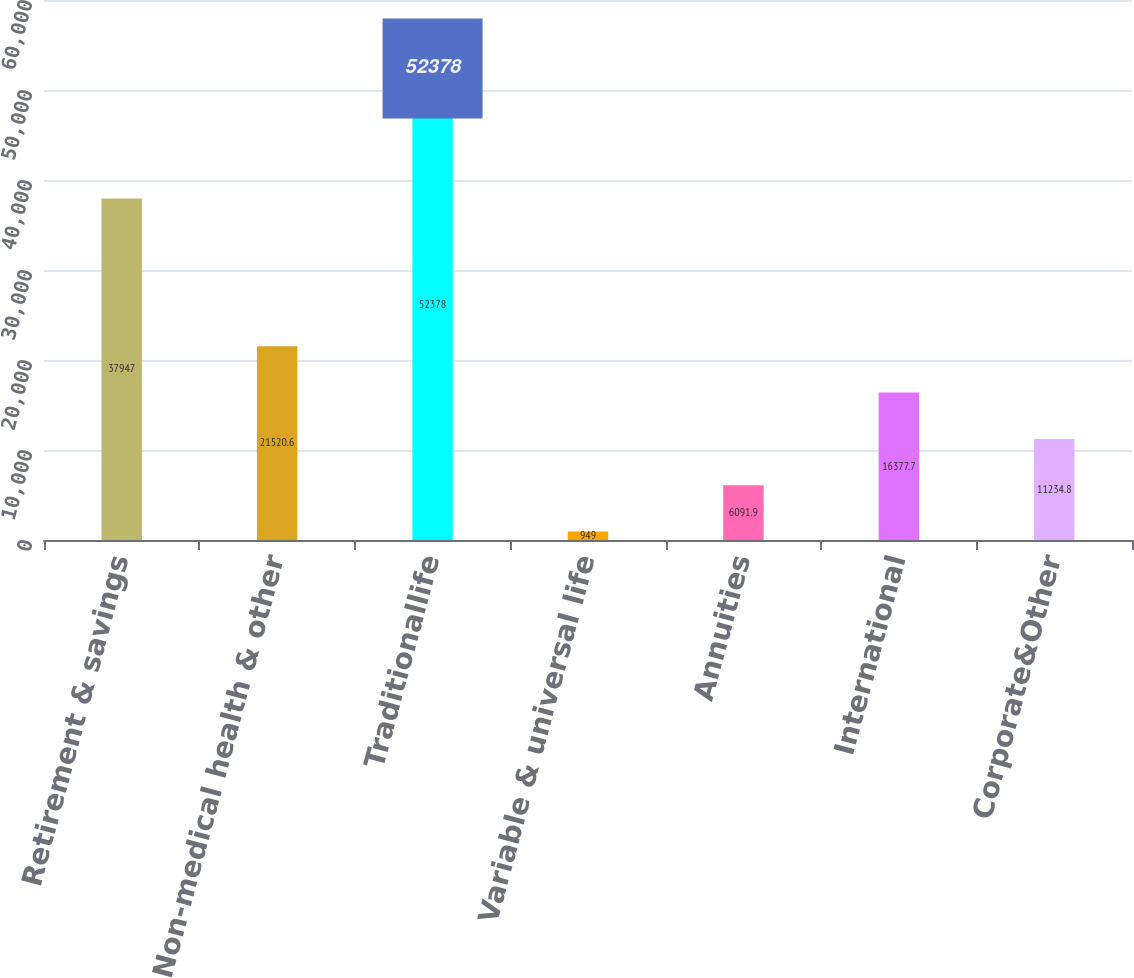Convert chart to OTSL. <chart><loc_0><loc_0><loc_500><loc_500><bar_chart><fcel>Retirement & savings<fcel>Non-medical health & other<fcel>Traditionallife<fcel>Variable & universal life<fcel>Annuities<fcel>International<fcel>Corporate&Other<nl><fcel>37947<fcel>21520.6<fcel>52378<fcel>949<fcel>6091.9<fcel>16377.7<fcel>11234.8<nl></chart> 